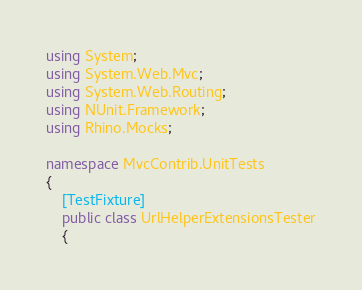Convert code to text. <code><loc_0><loc_0><loc_500><loc_500><_C#_>using System;
using System.Web.Mvc;
using System.Web.Routing;
using NUnit.Framework;
using Rhino.Mocks;

namespace MvcContrib.UnitTests
{
	[TestFixture]
	public class UrlHelperExtensionsTester
	{</code> 